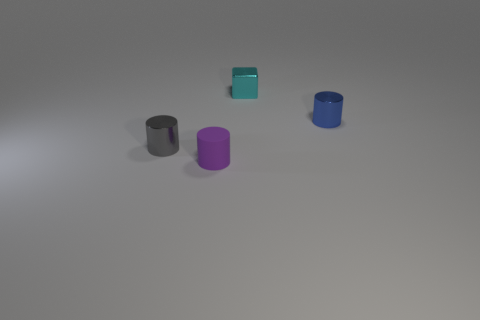What do the different colors of the objects signify? While the colors might be chosen simply for aesthetic contrast, they could also be indicative of different categories or levels in a coding system, or represent varied materials if they are educational models. Do the shadows cast by the objects tell us anything about the lighting in the scene? Yes, the shadows are soft and diffuse, suggesting the presence of a soft, broad light source, possibly overhead. The direction and length of shadows also help determine the object's three-dimensional form and the spatial relationships within the scene. 